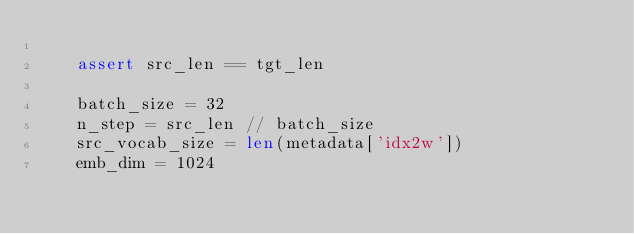<code> <loc_0><loc_0><loc_500><loc_500><_Python_>
    assert src_len == tgt_len

    batch_size = 32
    n_step = src_len // batch_size
    src_vocab_size = len(metadata['idx2w'])
    emb_dim = 1024
</code> 